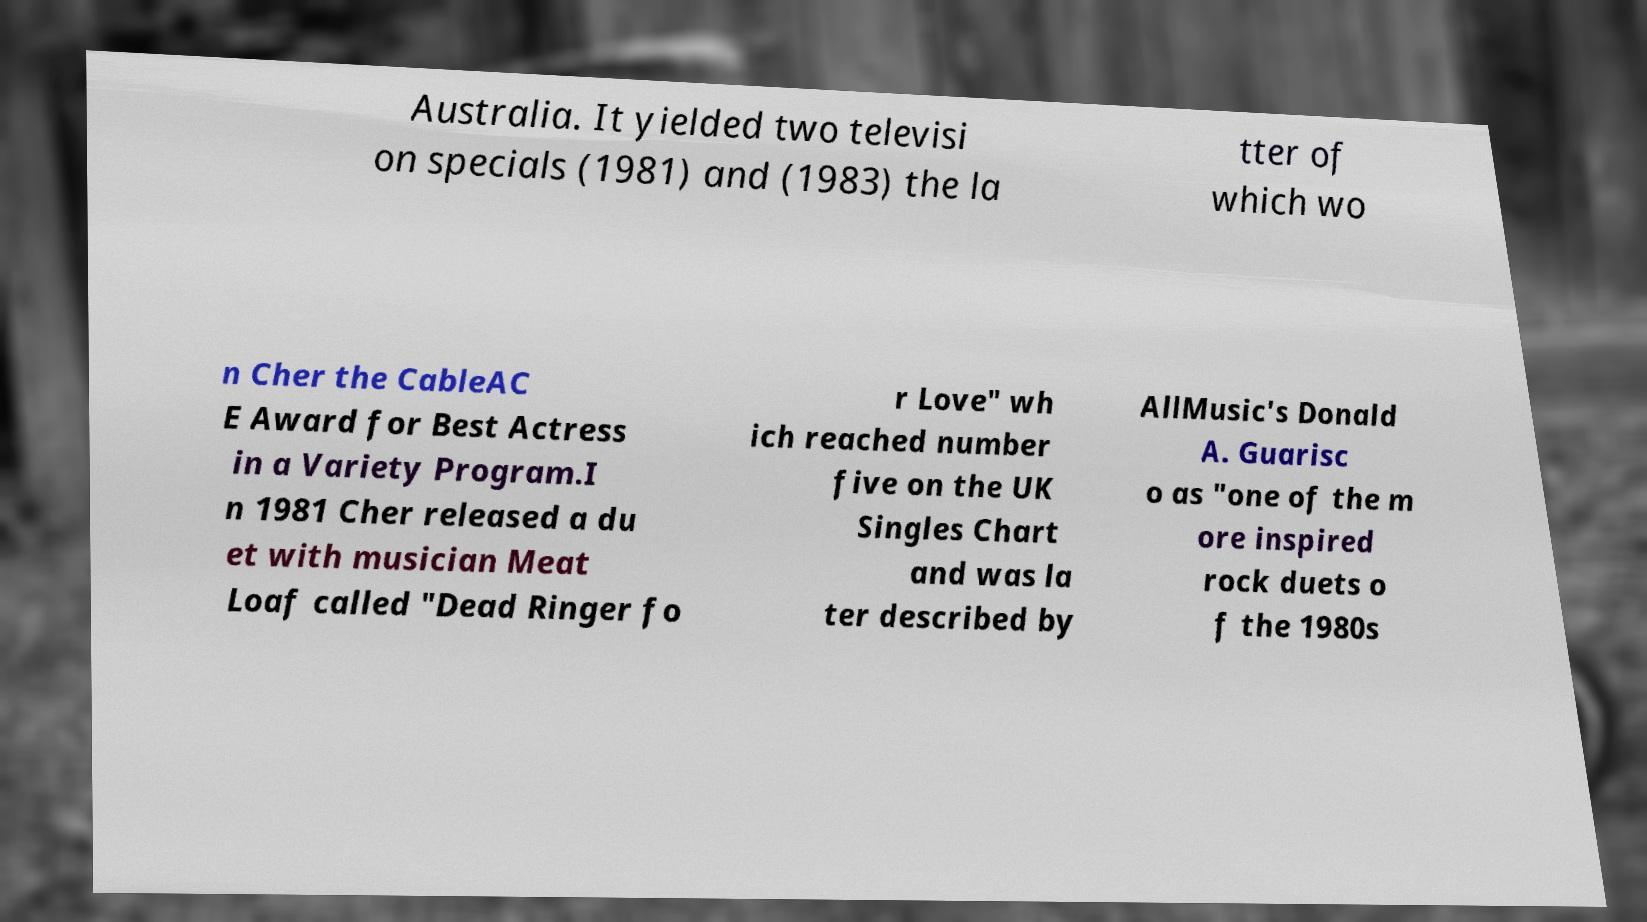Could you extract and type out the text from this image? Australia. It yielded two televisi on specials (1981) and (1983) the la tter of which wo n Cher the CableAC E Award for Best Actress in a Variety Program.I n 1981 Cher released a du et with musician Meat Loaf called "Dead Ringer fo r Love" wh ich reached number five on the UK Singles Chart and was la ter described by AllMusic's Donald A. Guarisc o as "one of the m ore inspired rock duets o f the 1980s 